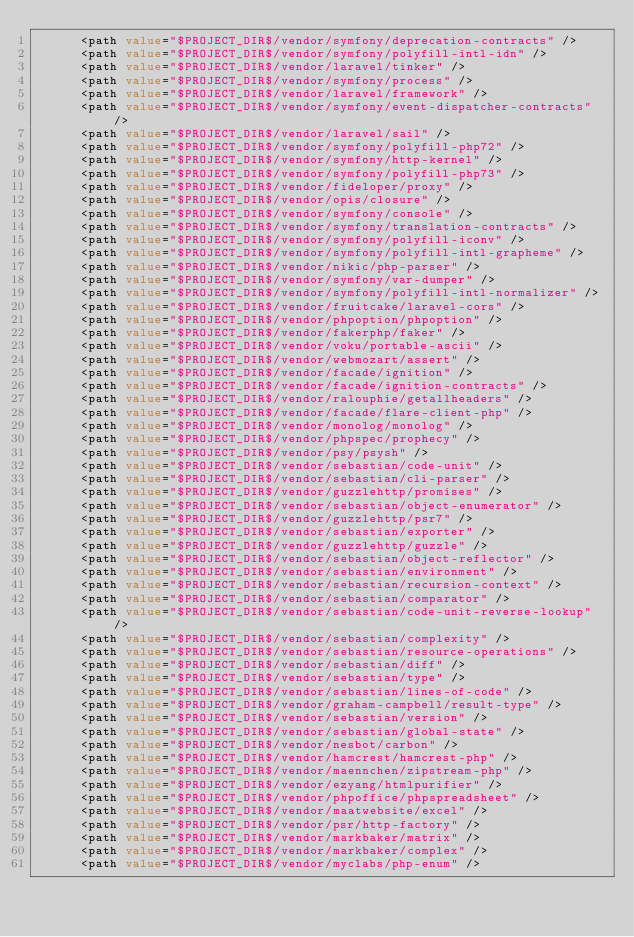Convert code to text. <code><loc_0><loc_0><loc_500><loc_500><_XML_>      <path value="$PROJECT_DIR$/vendor/symfony/deprecation-contracts" />
      <path value="$PROJECT_DIR$/vendor/symfony/polyfill-intl-idn" />
      <path value="$PROJECT_DIR$/vendor/laravel/tinker" />
      <path value="$PROJECT_DIR$/vendor/symfony/process" />
      <path value="$PROJECT_DIR$/vendor/laravel/framework" />
      <path value="$PROJECT_DIR$/vendor/symfony/event-dispatcher-contracts" />
      <path value="$PROJECT_DIR$/vendor/laravel/sail" />
      <path value="$PROJECT_DIR$/vendor/symfony/polyfill-php72" />
      <path value="$PROJECT_DIR$/vendor/symfony/http-kernel" />
      <path value="$PROJECT_DIR$/vendor/symfony/polyfill-php73" />
      <path value="$PROJECT_DIR$/vendor/fideloper/proxy" />
      <path value="$PROJECT_DIR$/vendor/opis/closure" />
      <path value="$PROJECT_DIR$/vendor/symfony/console" />
      <path value="$PROJECT_DIR$/vendor/symfony/translation-contracts" />
      <path value="$PROJECT_DIR$/vendor/symfony/polyfill-iconv" />
      <path value="$PROJECT_DIR$/vendor/symfony/polyfill-intl-grapheme" />
      <path value="$PROJECT_DIR$/vendor/nikic/php-parser" />
      <path value="$PROJECT_DIR$/vendor/symfony/var-dumper" />
      <path value="$PROJECT_DIR$/vendor/symfony/polyfill-intl-normalizer" />
      <path value="$PROJECT_DIR$/vendor/fruitcake/laravel-cors" />
      <path value="$PROJECT_DIR$/vendor/phpoption/phpoption" />
      <path value="$PROJECT_DIR$/vendor/fakerphp/faker" />
      <path value="$PROJECT_DIR$/vendor/voku/portable-ascii" />
      <path value="$PROJECT_DIR$/vendor/webmozart/assert" />
      <path value="$PROJECT_DIR$/vendor/facade/ignition" />
      <path value="$PROJECT_DIR$/vendor/facade/ignition-contracts" />
      <path value="$PROJECT_DIR$/vendor/ralouphie/getallheaders" />
      <path value="$PROJECT_DIR$/vendor/facade/flare-client-php" />
      <path value="$PROJECT_DIR$/vendor/monolog/monolog" />
      <path value="$PROJECT_DIR$/vendor/phpspec/prophecy" />
      <path value="$PROJECT_DIR$/vendor/psy/psysh" />
      <path value="$PROJECT_DIR$/vendor/sebastian/code-unit" />
      <path value="$PROJECT_DIR$/vendor/sebastian/cli-parser" />
      <path value="$PROJECT_DIR$/vendor/guzzlehttp/promises" />
      <path value="$PROJECT_DIR$/vendor/sebastian/object-enumerator" />
      <path value="$PROJECT_DIR$/vendor/guzzlehttp/psr7" />
      <path value="$PROJECT_DIR$/vendor/sebastian/exporter" />
      <path value="$PROJECT_DIR$/vendor/guzzlehttp/guzzle" />
      <path value="$PROJECT_DIR$/vendor/sebastian/object-reflector" />
      <path value="$PROJECT_DIR$/vendor/sebastian/environment" />
      <path value="$PROJECT_DIR$/vendor/sebastian/recursion-context" />
      <path value="$PROJECT_DIR$/vendor/sebastian/comparator" />
      <path value="$PROJECT_DIR$/vendor/sebastian/code-unit-reverse-lookup" />
      <path value="$PROJECT_DIR$/vendor/sebastian/complexity" />
      <path value="$PROJECT_DIR$/vendor/sebastian/resource-operations" />
      <path value="$PROJECT_DIR$/vendor/sebastian/diff" />
      <path value="$PROJECT_DIR$/vendor/sebastian/type" />
      <path value="$PROJECT_DIR$/vendor/sebastian/lines-of-code" />
      <path value="$PROJECT_DIR$/vendor/graham-campbell/result-type" />
      <path value="$PROJECT_DIR$/vendor/sebastian/version" />
      <path value="$PROJECT_DIR$/vendor/sebastian/global-state" />
      <path value="$PROJECT_DIR$/vendor/nesbot/carbon" />
      <path value="$PROJECT_DIR$/vendor/hamcrest/hamcrest-php" />
      <path value="$PROJECT_DIR$/vendor/maennchen/zipstream-php" />
      <path value="$PROJECT_DIR$/vendor/ezyang/htmlpurifier" />
      <path value="$PROJECT_DIR$/vendor/phpoffice/phpspreadsheet" />
      <path value="$PROJECT_DIR$/vendor/maatwebsite/excel" />
      <path value="$PROJECT_DIR$/vendor/psr/http-factory" />
      <path value="$PROJECT_DIR$/vendor/markbaker/matrix" />
      <path value="$PROJECT_DIR$/vendor/markbaker/complex" />
      <path value="$PROJECT_DIR$/vendor/myclabs/php-enum" /></code> 